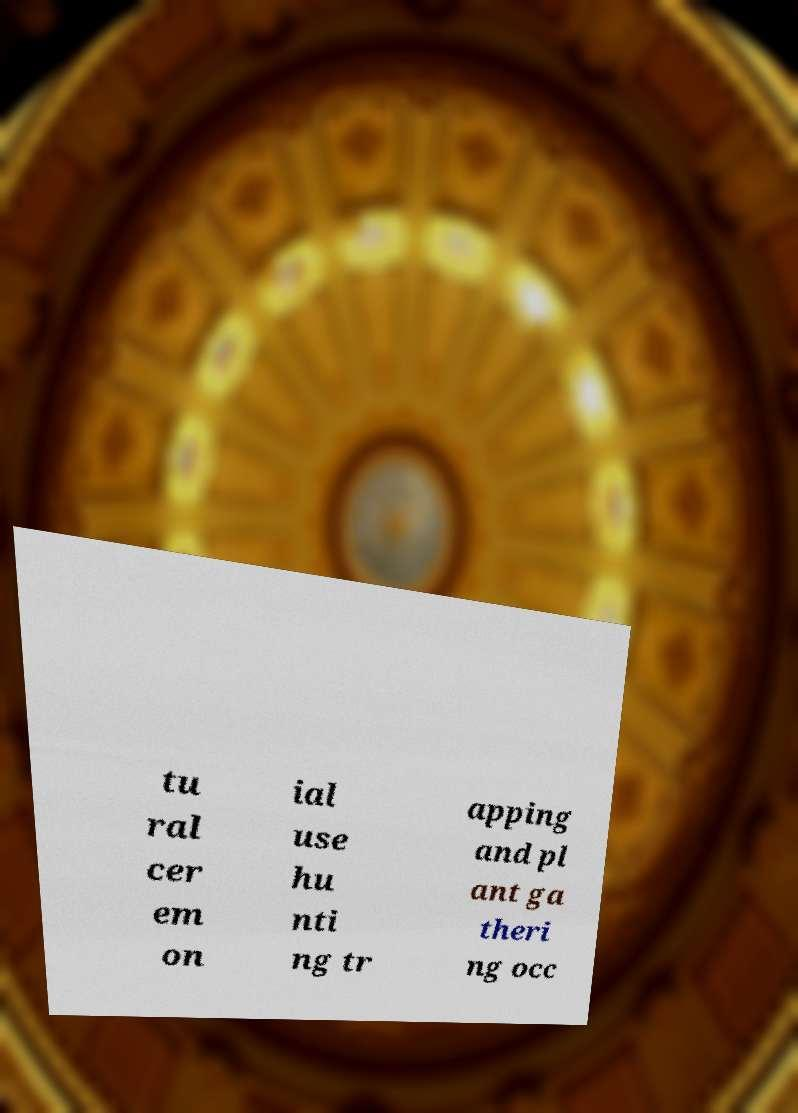Can you accurately transcribe the text from the provided image for me? tu ral cer em on ial use hu nti ng tr apping and pl ant ga theri ng occ 